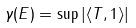<formula> <loc_0><loc_0><loc_500><loc_500>\gamma ( E ) = \sup | \langle T , 1 \rangle |</formula> 